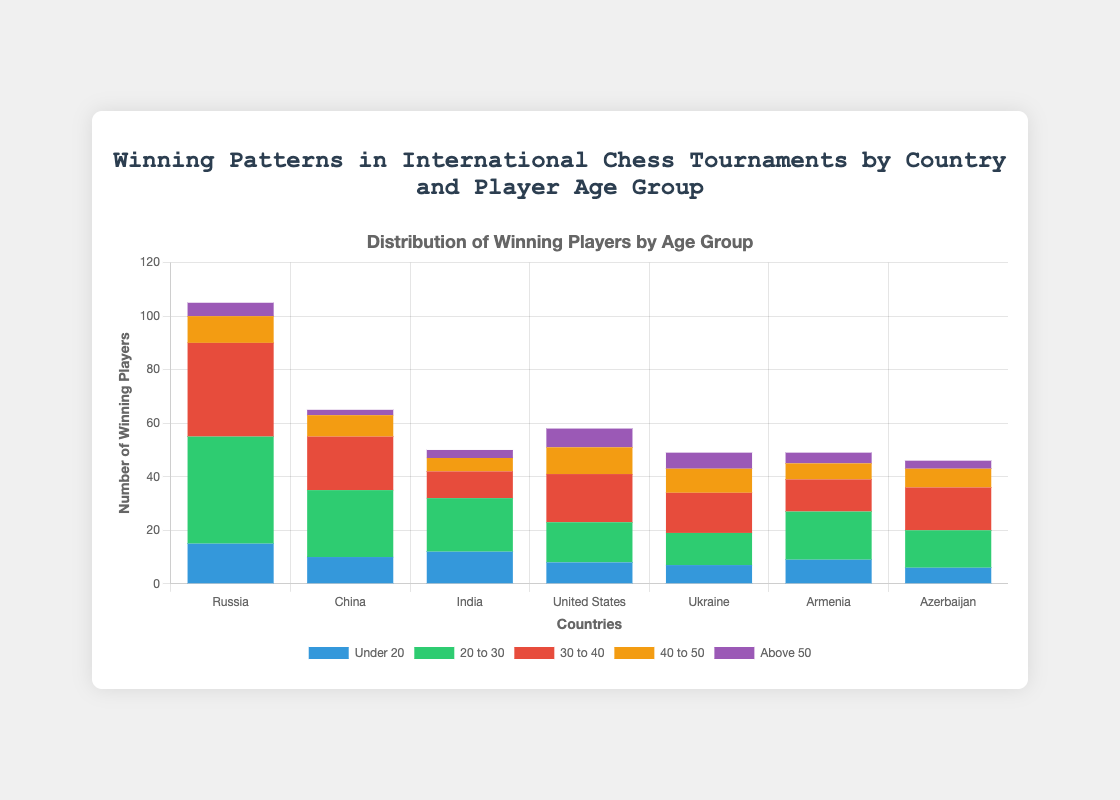Which country has the highest number of winning players in the age group '20 to 30'? To find the country with the highest number of winning players in the '20 to 30' age group, look at the height of the green bars. Comparing the green bars across all countries, Russia has the highest bar with 40 winning players.
Answer: Russia How many total winning players does India have across all age groups? Sum the values for India across all age groups: 12 (Under20) + 20 (20to30) + 10 (30to40) + 5 (40to50) + 3 (Above50) = 50. So, India has a total of 50 winning players.
Answer: 50 Which two countries have the closest total number of winning players? Calculate the total number of winning players for each country and compare them: 
- Russia: 105 
- China: 65 
- India: 50 
- United States: 58 
- Ukraine: 49 
- Armenia: 49 
- Azerbaijan: 46 
The two closest totals are Ukraine and Armenia, both with 49 winning players.
Answer: Ukraine and Armenia What's the difference in the number of winning players between China and the United States in the '30 to 40' age group? Compare the value for China (20) with the United States (18) in the '30 to 40' age group. The difference is 20 - 18 = 2.
Answer: 2 How many winning players above 50 years old come from Russia and Azerbaijan combined? Add the values for the 'Above50' age group for Russia and Azerbaijan: 5 (Russia) + 3 (Azerbaijan) = 8.
Answer: 8 Is the number of winning players under 20 higher in Armenia or Azerbaijan? Compare the values for the 'Under20' age group: Armenia has 9 and Azerbaijan has 6, so Armenia has a higher number.
Answer: Armenia Which age group contributes the most to the total number of winning players in Ukraine? Look at the bars for each age group in Ukraine and find that the '30 to 40' group has the highest value with 15 winning players.
Answer: 30 to 40 What’s the average number of winning players in the '40 to 50' age group for all countries? Sum the numbers in the '40 to 50' age group for all countries: 10 (Russia) + 8 (China) + 5 (India) + 10 (United States) + 9 (Ukraine) + 6 (Armenia) + 7 (Azerbaijan) = 55. Then, divide by the number of countries: 55 / 7 ≈ 7.86.
Answer: 7.86 